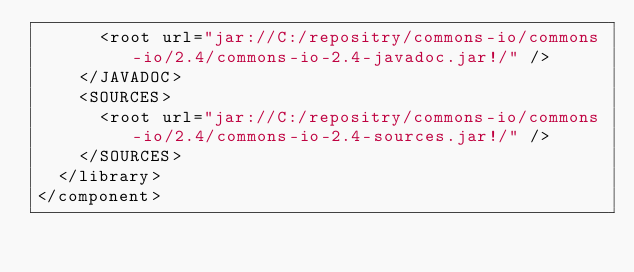Convert code to text. <code><loc_0><loc_0><loc_500><loc_500><_XML_>      <root url="jar://C:/repositry/commons-io/commons-io/2.4/commons-io-2.4-javadoc.jar!/" />
    </JAVADOC>
    <SOURCES>
      <root url="jar://C:/repositry/commons-io/commons-io/2.4/commons-io-2.4-sources.jar!/" />
    </SOURCES>
  </library>
</component></code> 